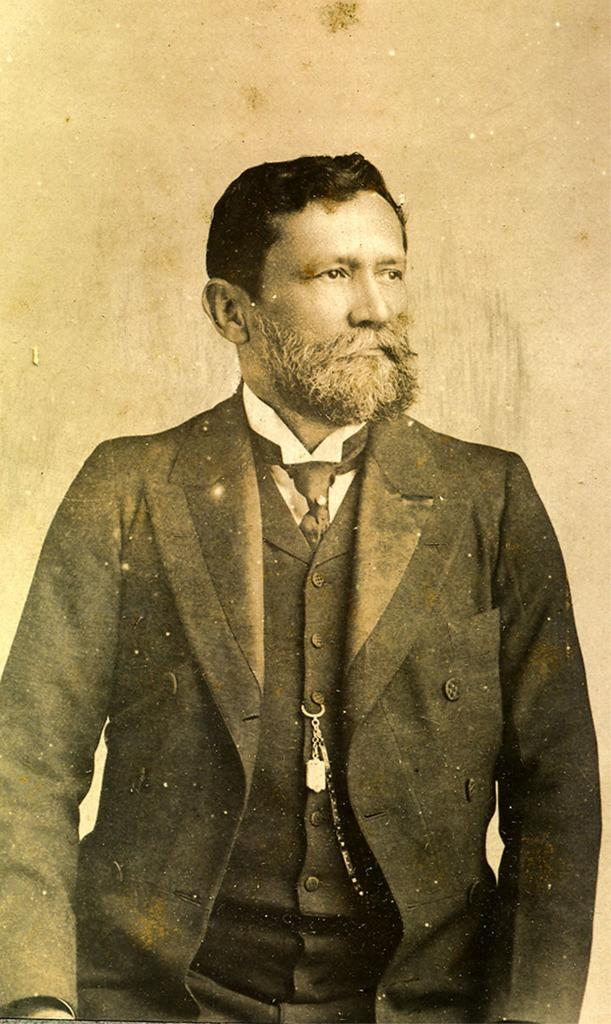What is the main subject of the image? The main subject of the image is a man. What type of clothing is the man wearing? The man is wearing a coat, a shirt, a tie, and a vest. What can be said about the color scheme of the image? The image is black and white in color. How many legs does the ornament have in the image? There is no ornament present in the image, so it is not possible to determine the number of legs it might have. 